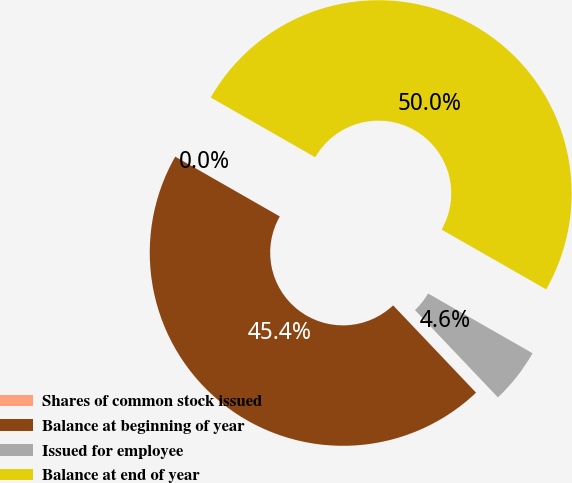<chart> <loc_0><loc_0><loc_500><loc_500><pie_chart><fcel>Shares of common stock issued<fcel>Balance at beginning of year<fcel>Issued for employee<fcel>Balance at end of year<nl><fcel>0.0%<fcel>45.36%<fcel>4.64%<fcel>50.0%<nl></chart> 